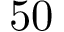Convert formula to latex. <formula><loc_0><loc_0><loc_500><loc_500>5 0</formula> 